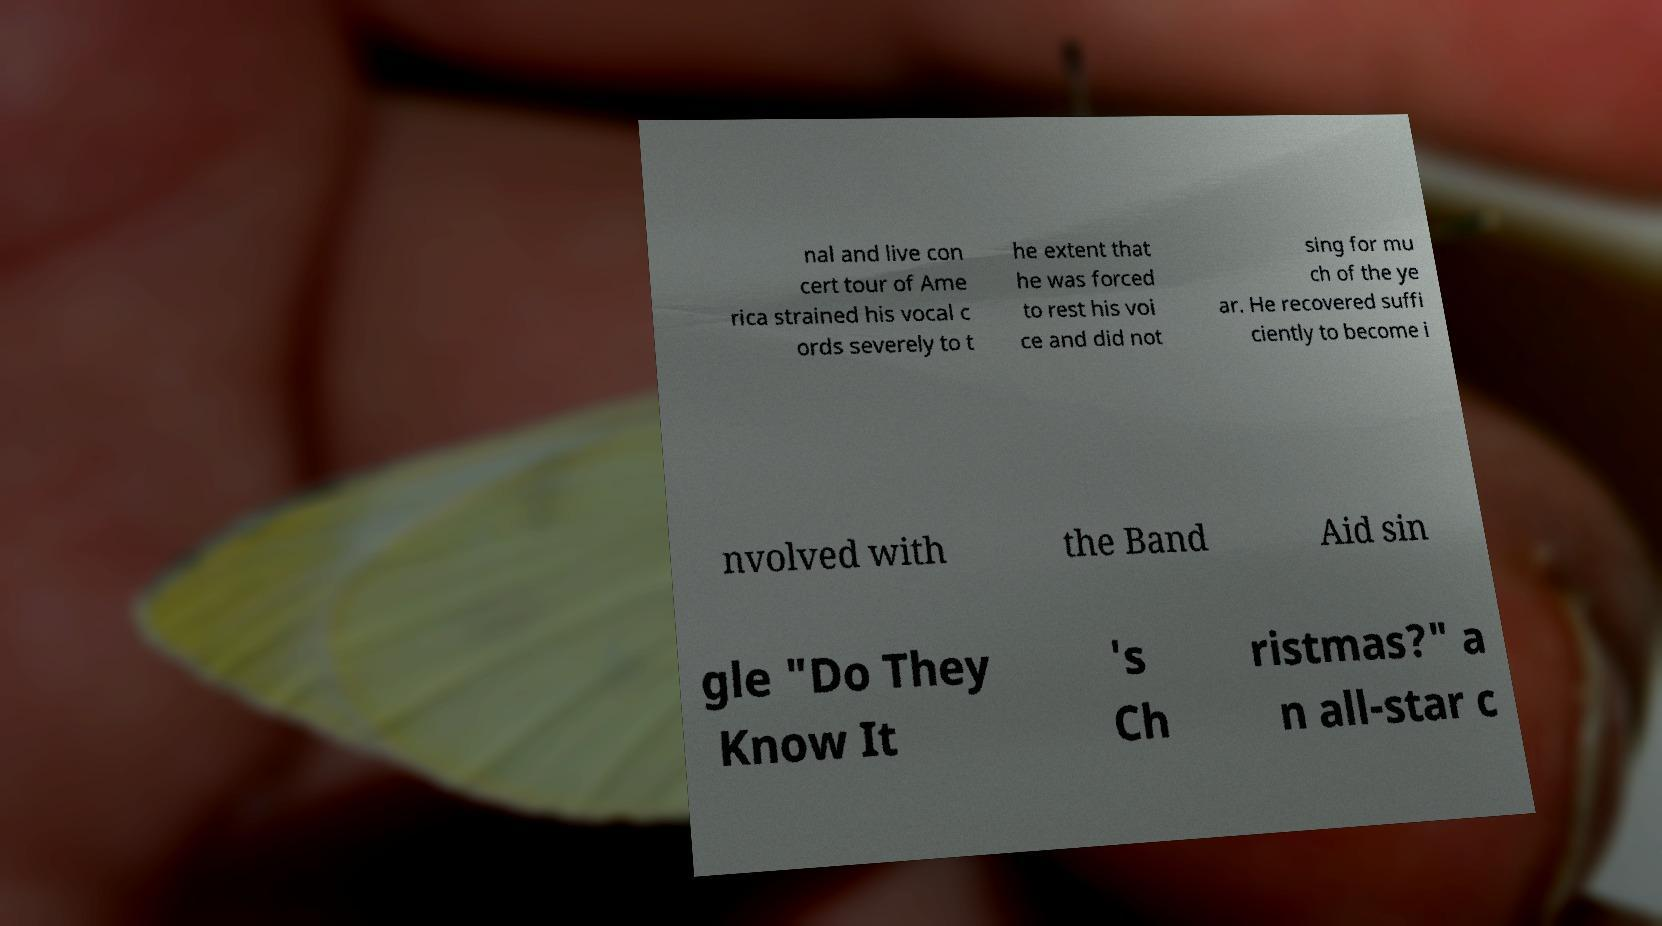Please identify and transcribe the text found in this image. nal and live con cert tour of Ame rica strained his vocal c ords severely to t he extent that he was forced to rest his voi ce and did not sing for mu ch of the ye ar. He recovered suffi ciently to become i nvolved with the Band Aid sin gle "Do They Know It 's Ch ristmas?" a n all-star c 